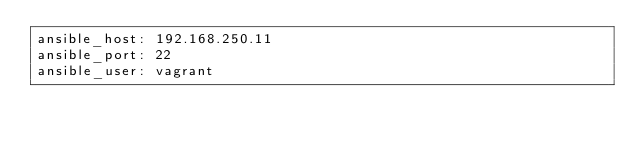Convert code to text. <code><loc_0><loc_0><loc_500><loc_500><_YAML_>ansible_host: 192.168.250.11
ansible_port: 22
ansible_user: vagrant
</code> 